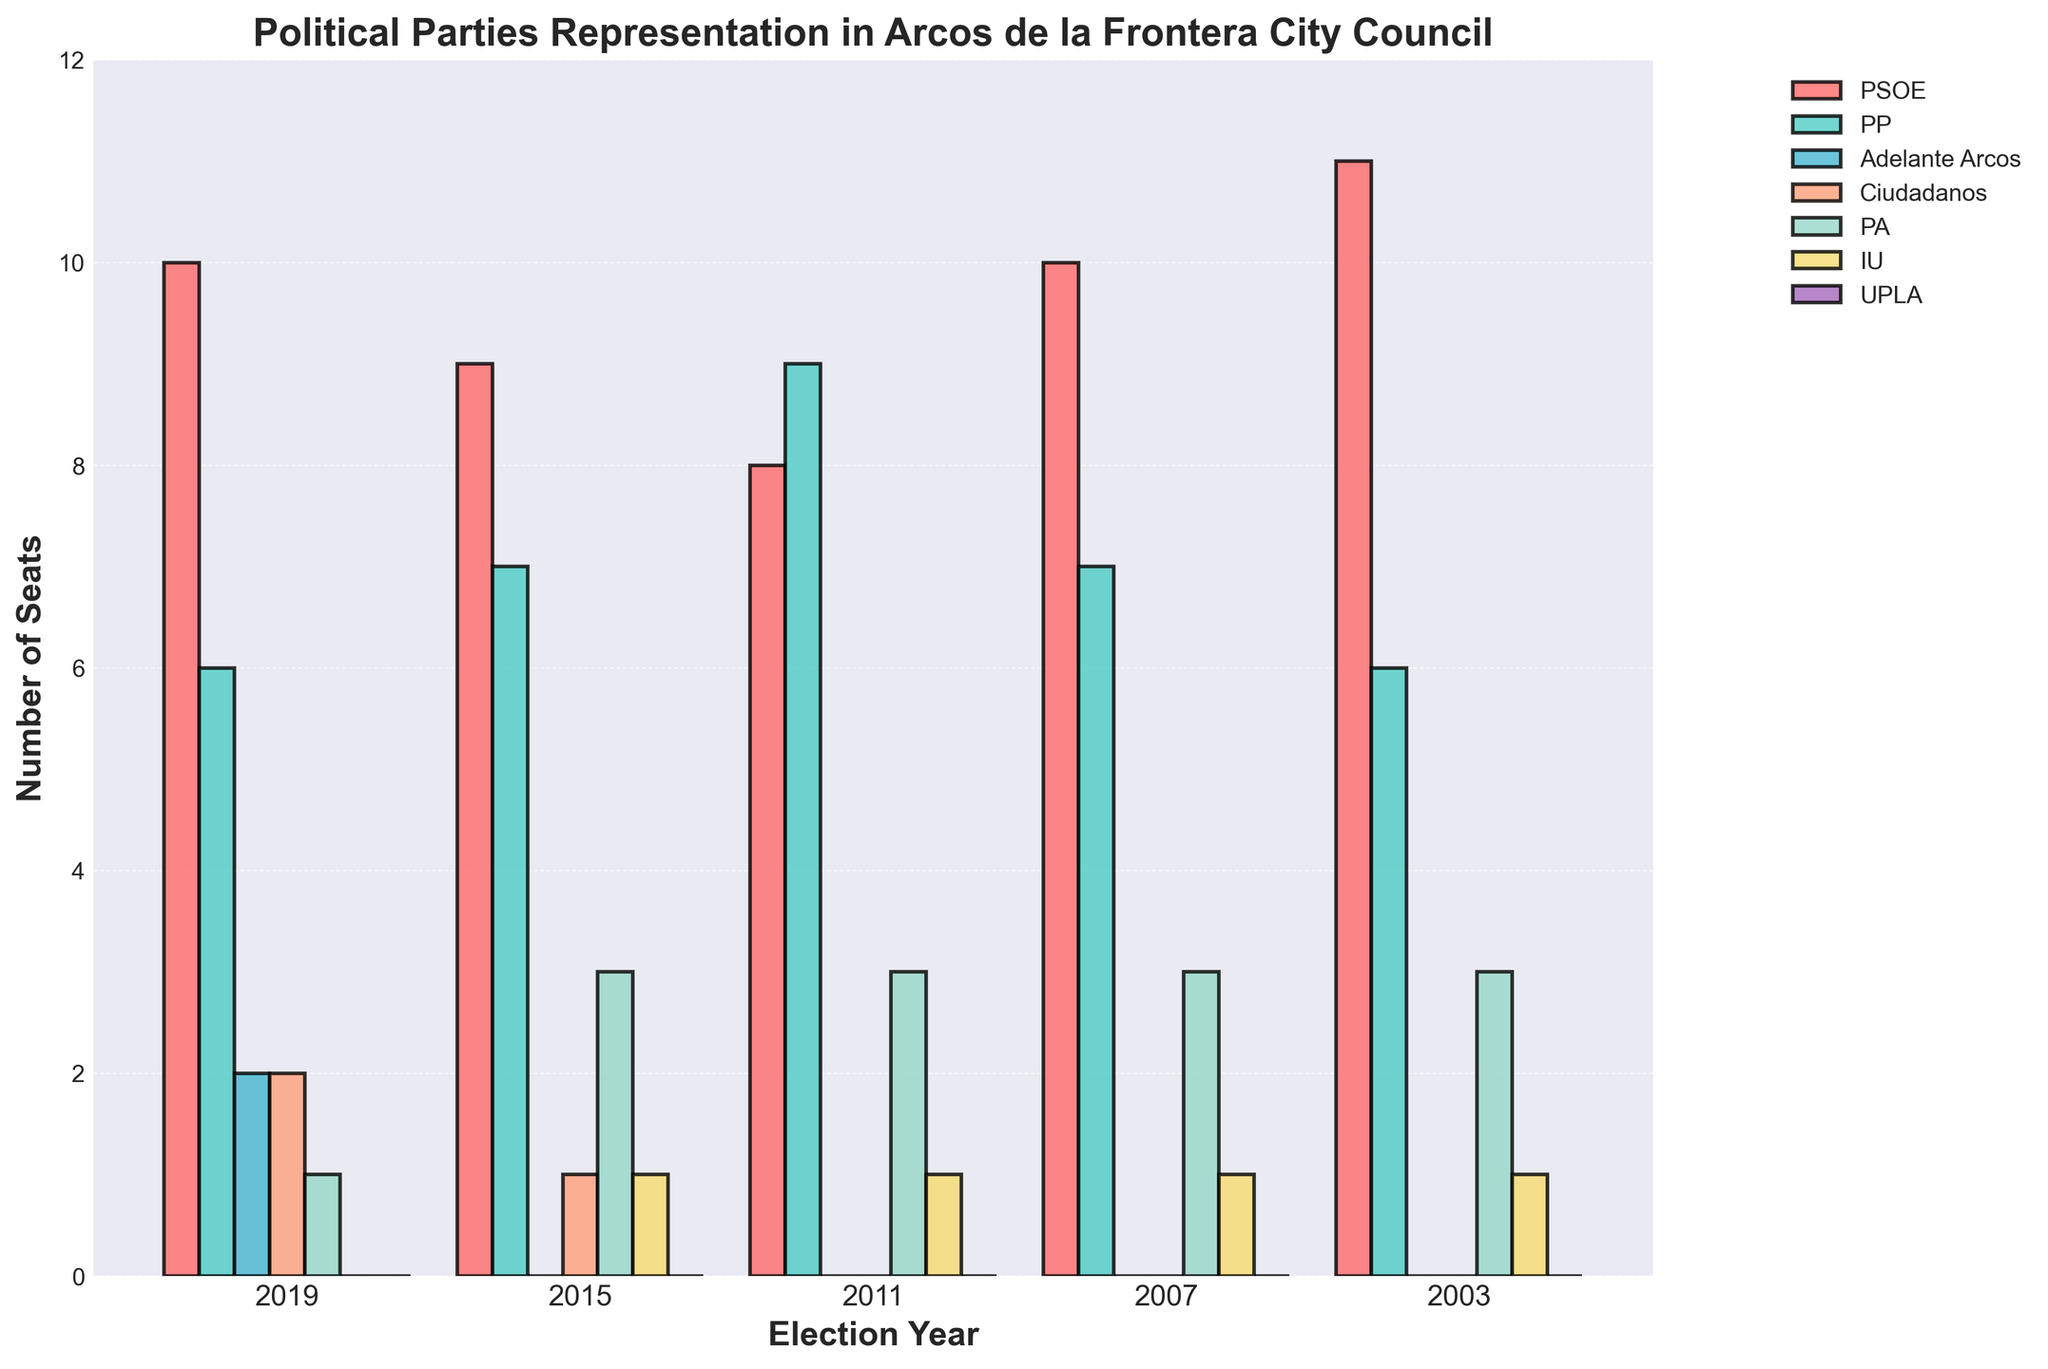How many more seats did the PSOE win in 2003 compared to 2015? In 2003, PSOE won 11 seats, and in 2015, PSOE won 9 seats. The difference is calculated by subtracting the 2015 seats from the 2003 seats: 11 - 9 = 2
Answer: 2 Which party had the most seats in 2011? By visually comparing the heights of the bars in the 2011 section of the chart, the PP (center-right) has the highest bar, indicating the most seats
Answer: PP How many seats in total did IU win over the 5 elections? Add the number of seats IU won across all the years: 0 (2019) + 1 (2015) + 1 (2011) + 1 (2007) + 1 (2003) = 4
Answer: 4 Which party’s representation decreased the most from 2007 to 2011? By comparing the party seats between the two years, the PSOE shows the most significant decrease, dropping from 10 to 8 seats
Answer: PSOE What is the average number of seats Ciudadanos won over the elections they participated in? Ciudadanos participated in the 2015 and 2019 elections. The total number of seats they won is 1 (2015) + 2 (2019) = 3. The average is calculated as 3 / 2 = 1.5
Answer: 1.5 Which year saw the highest number of total seats for parties other than PSOE and PP? For each year, sum the seats of parties other than PSOE and PP and compare: 
- 2019: 2 (Adelante Arcos) + 2 (Ciudadanos) + 1 (PA) = 5
- 2015: 1 (Ciudadanos) + 3 (PA) + 1 (IU) = 5
- 2011: 3 (PA) + 1 (IU) = 4
- 2007: 3 (PA) + 1 (IU) = 4
- 2003: 3 (PA) + 1 (IU) = 4
The highest value is 5, occurring in 2019 and 2015
Answer: 2019 and 2015 If each seat represents one council member, how many different parties were represented in the 2003 council? Observing the 2003 bars, parties represented with non-zero seats are PSOE, PP, PA, and IU, tallying up to 4 different parties
Answer: 4 How many seats did Adelante Arcos win across all elections displayed? Adelante Arcos only participated in the 2019 elections, winning 2 seats. Thus, their total number of seats is 2
Answer: 2 Which party’s representation remained constant over the five elections? Comparing the bars for each party across all five years reveals that Adelante Arcos did not participate in any other election except 2019, but IU consistently won 1 seat from 2003 to 2011 and only participated in one election thereafter without change in seats, but only from 2015 to 2019 IU had none, leading to a change in counts
Answer: None 